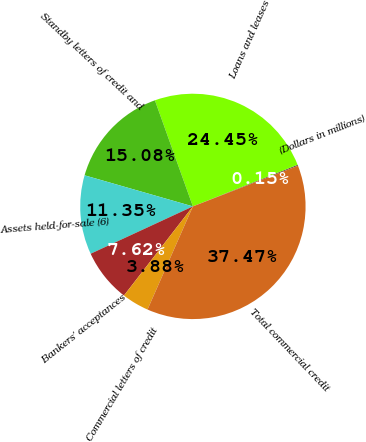Convert chart to OTSL. <chart><loc_0><loc_0><loc_500><loc_500><pie_chart><fcel>(Dollars in millions)<fcel>Loans and leases<fcel>Standby letters of credit and<fcel>Assets held-for-sale (6)<fcel>Bankers' acceptances<fcel>Commercial letters of credit<fcel>Total commercial credit<nl><fcel>0.15%<fcel>24.45%<fcel>15.08%<fcel>11.35%<fcel>7.62%<fcel>3.88%<fcel>37.47%<nl></chart> 